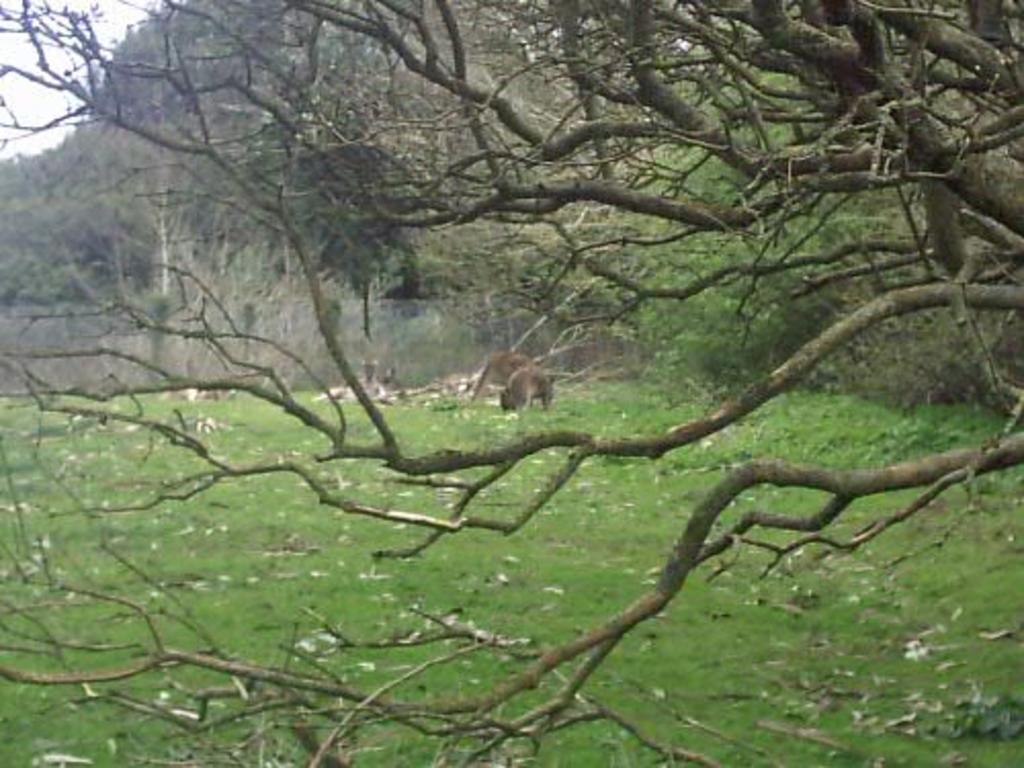What type of vegetation is present in the image? There are trees in the image. What type of barrier can be seen in the image? There is a fence in the image. What is on the ground in the image? There is a group of animals on the ground in the image. What part of the sky is visible in the image? The sky is visible in the top left corner of the image. What might be the location of the image based on the vegetation? The image may have been taken in a forest, given the presence of trees. What type of chalk is being used by the animals in the image? There is no chalk present in the image, and the animals are not using any chalk. What is being served for dinner in the image? There is no dinner being served in the image; it features a group of animals on the ground. 